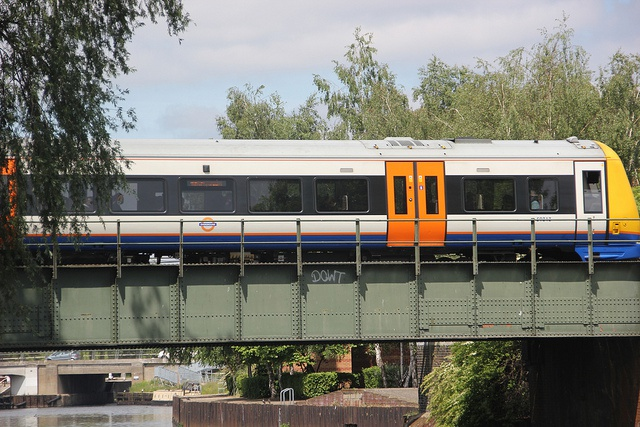Describe the objects in this image and their specific colors. I can see train in lightgray, black, gray, and navy tones, car in lightgray, black, gray, darkgreen, and darkgray tones, car in lightgray, darkgray, and gray tones, people in lightgray, gray, black, and purple tones, and people in lightgray, black, and gray tones in this image. 